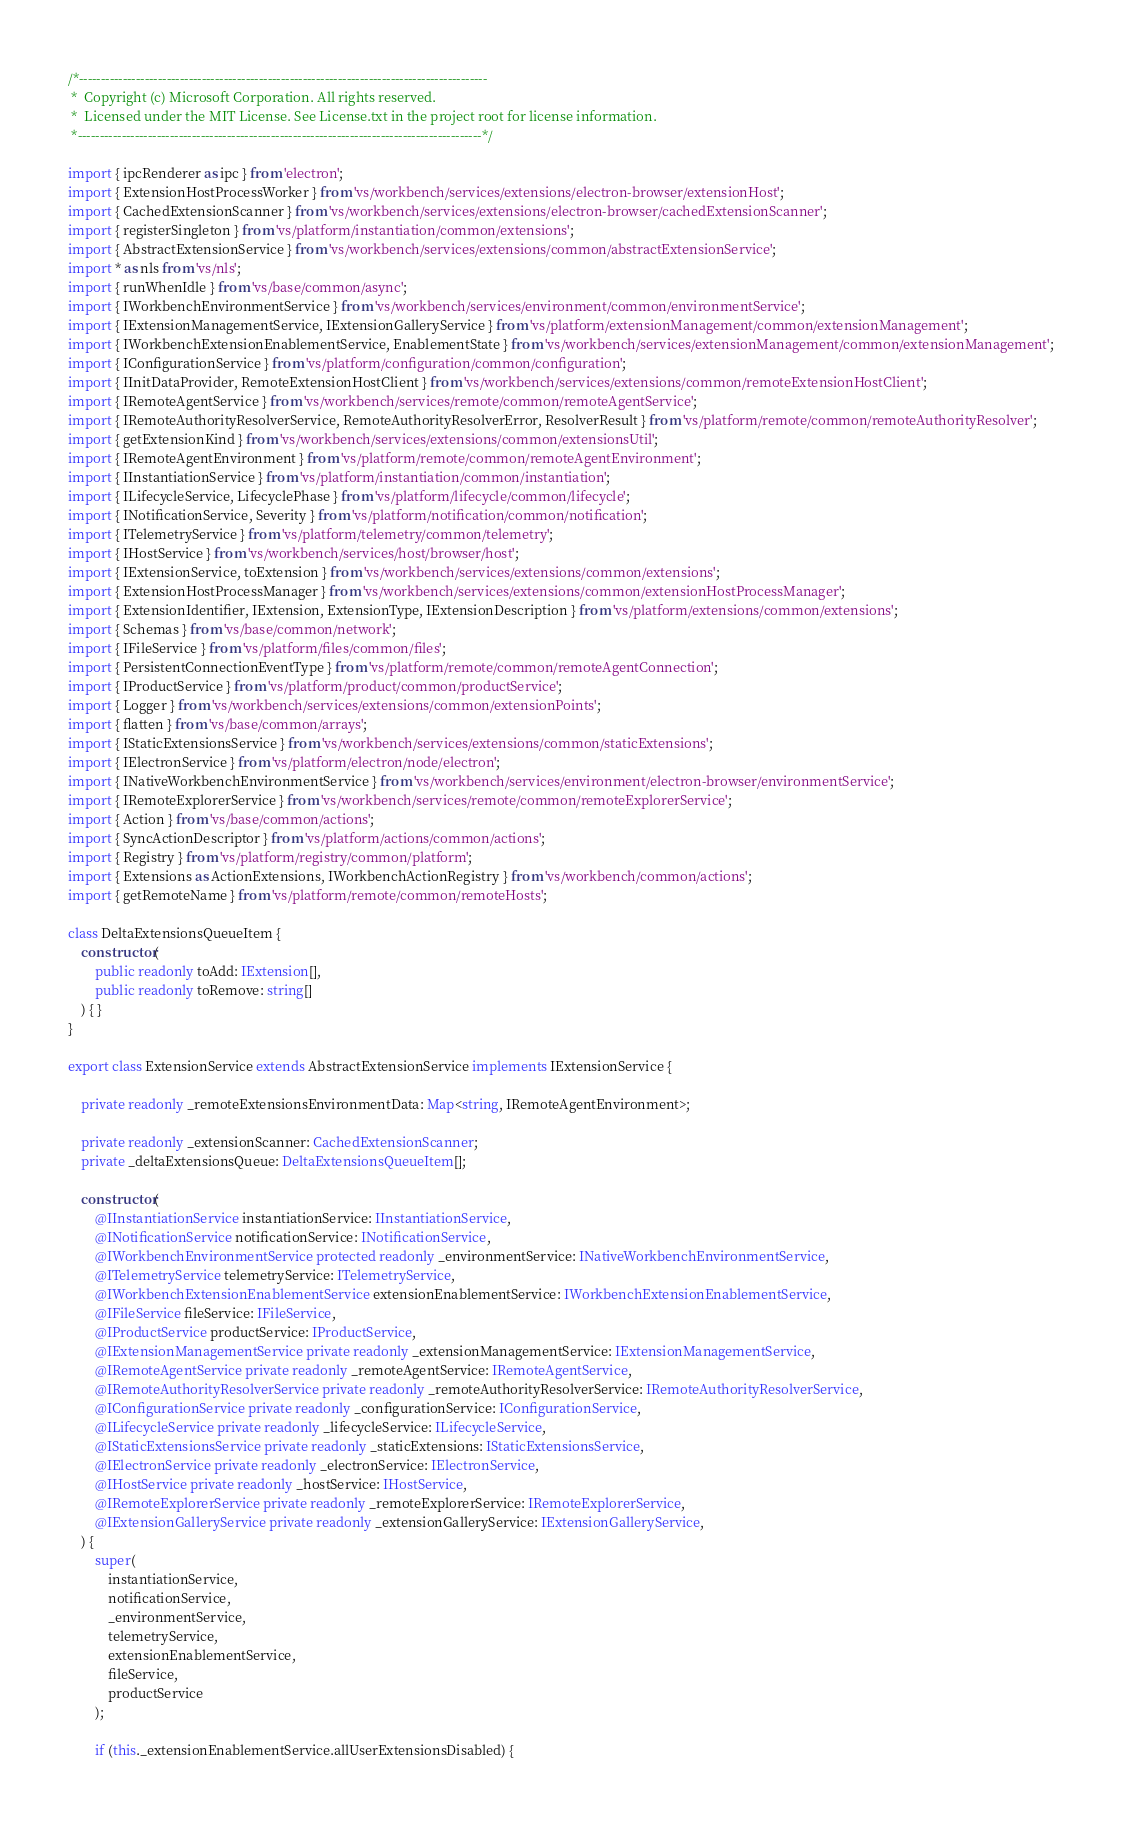<code> <loc_0><loc_0><loc_500><loc_500><_TypeScript_>/*---------------------------------------------------------------------------------------------
 *  Copyright (c) Microsoft Corporation. All rights reserved.
 *  Licensed under the MIT License. See License.txt in the project root for license information.
 *--------------------------------------------------------------------------------------------*/

import { ipcRenderer as ipc } from 'electron';
import { ExtensionHostProcessWorker } from 'vs/workbench/services/extensions/electron-browser/extensionHost';
import { CachedExtensionScanner } from 'vs/workbench/services/extensions/electron-browser/cachedExtensionScanner';
import { registerSingleton } from 'vs/platform/instantiation/common/extensions';
import { AbstractExtensionService } from 'vs/workbench/services/extensions/common/abstractExtensionService';
import * as nls from 'vs/nls';
import { runWhenIdle } from 'vs/base/common/async';
import { IWorkbenchEnvironmentService } from 'vs/workbench/services/environment/common/environmentService';
import { IExtensionManagementService, IExtensionGalleryService } from 'vs/platform/extensionManagement/common/extensionManagement';
import { IWorkbenchExtensionEnablementService, EnablementState } from 'vs/workbench/services/extensionManagement/common/extensionManagement';
import { IConfigurationService } from 'vs/platform/configuration/common/configuration';
import { IInitDataProvider, RemoteExtensionHostClient } from 'vs/workbench/services/extensions/common/remoteExtensionHostClient';
import { IRemoteAgentService } from 'vs/workbench/services/remote/common/remoteAgentService';
import { IRemoteAuthorityResolverService, RemoteAuthorityResolverError, ResolverResult } from 'vs/platform/remote/common/remoteAuthorityResolver';
import { getExtensionKind } from 'vs/workbench/services/extensions/common/extensionsUtil';
import { IRemoteAgentEnvironment } from 'vs/platform/remote/common/remoteAgentEnvironment';
import { IInstantiationService } from 'vs/platform/instantiation/common/instantiation';
import { ILifecycleService, LifecyclePhase } from 'vs/platform/lifecycle/common/lifecycle';
import { INotificationService, Severity } from 'vs/platform/notification/common/notification';
import { ITelemetryService } from 'vs/platform/telemetry/common/telemetry';
import { IHostService } from 'vs/workbench/services/host/browser/host';
import { IExtensionService, toExtension } from 'vs/workbench/services/extensions/common/extensions';
import { ExtensionHostProcessManager } from 'vs/workbench/services/extensions/common/extensionHostProcessManager';
import { ExtensionIdentifier, IExtension, ExtensionType, IExtensionDescription } from 'vs/platform/extensions/common/extensions';
import { Schemas } from 'vs/base/common/network';
import { IFileService } from 'vs/platform/files/common/files';
import { PersistentConnectionEventType } from 'vs/platform/remote/common/remoteAgentConnection';
import { IProductService } from 'vs/platform/product/common/productService';
import { Logger } from 'vs/workbench/services/extensions/common/extensionPoints';
import { flatten } from 'vs/base/common/arrays';
import { IStaticExtensionsService } from 'vs/workbench/services/extensions/common/staticExtensions';
import { IElectronService } from 'vs/platform/electron/node/electron';
import { INativeWorkbenchEnvironmentService } from 'vs/workbench/services/environment/electron-browser/environmentService';
import { IRemoteExplorerService } from 'vs/workbench/services/remote/common/remoteExplorerService';
import { Action } from 'vs/base/common/actions';
import { SyncActionDescriptor } from 'vs/platform/actions/common/actions';
import { Registry } from 'vs/platform/registry/common/platform';
import { Extensions as ActionExtensions, IWorkbenchActionRegistry } from 'vs/workbench/common/actions';
import { getRemoteName } from 'vs/platform/remote/common/remoteHosts';

class DeltaExtensionsQueueItem {
	constructor(
		public readonly toAdd: IExtension[],
		public readonly toRemove: string[]
	) { }
}

export class ExtensionService extends AbstractExtensionService implements IExtensionService {

	private readonly _remoteExtensionsEnvironmentData: Map<string, IRemoteAgentEnvironment>;

	private readonly _extensionScanner: CachedExtensionScanner;
	private _deltaExtensionsQueue: DeltaExtensionsQueueItem[];

	constructor(
		@IInstantiationService instantiationService: IInstantiationService,
		@INotificationService notificationService: INotificationService,
		@IWorkbenchEnvironmentService protected readonly _environmentService: INativeWorkbenchEnvironmentService,
		@ITelemetryService telemetryService: ITelemetryService,
		@IWorkbenchExtensionEnablementService extensionEnablementService: IWorkbenchExtensionEnablementService,
		@IFileService fileService: IFileService,
		@IProductService productService: IProductService,
		@IExtensionManagementService private readonly _extensionManagementService: IExtensionManagementService,
		@IRemoteAgentService private readonly _remoteAgentService: IRemoteAgentService,
		@IRemoteAuthorityResolverService private readonly _remoteAuthorityResolverService: IRemoteAuthorityResolverService,
		@IConfigurationService private readonly _configurationService: IConfigurationService,
		@ILifecycleService private readonly _lifecycleService: ILifecycleService,
		@IStaticExtensionsService private readonly _staticExtensions: IStaticExtensionsService,
		@IElectronService private readonly _electronService: IElectronService,
		@IHostService private readonly _hostService: IHostService,
		@IRemoteExplorerService private readonly _remoteExplorerService: IRemoteExplorerService,
		@IExtensionGalleryService private readonly _extensionGalleryService: IExtensionGalleryService,
	) {
		super(
			instantiationService,
			notificationService,
			_environmentService,
			telemetryService,
			extensionEnablementService,
			fileService,
			productService
		);

		if (this._extensionEnablementService.allUserExtensionsDisabled) {</code> 